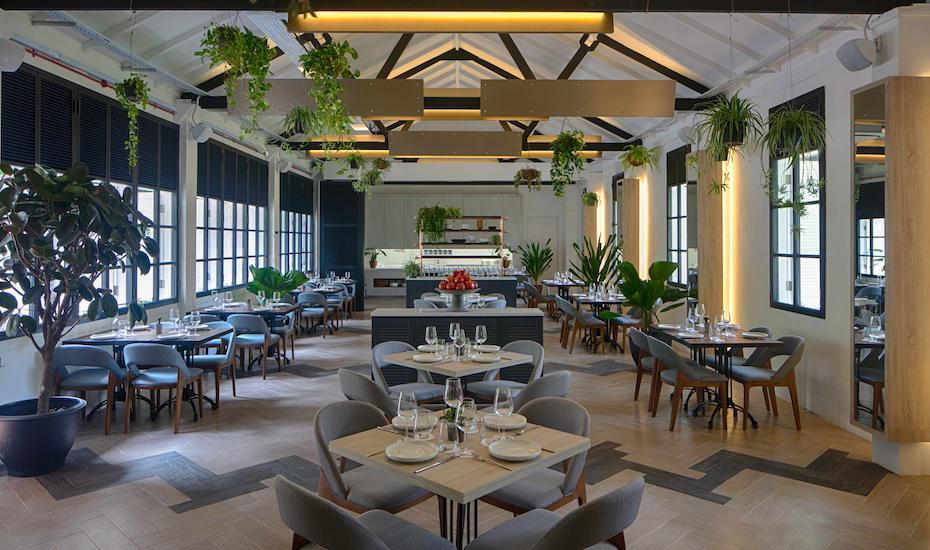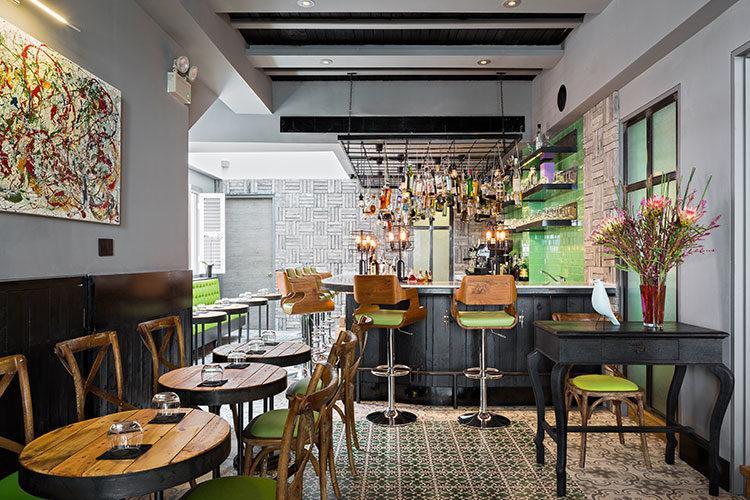The first image is the image on the left, the second image is the image on the right. Examine the images to the left and right. Is the description "Some tables have glass candle holders on them." accurate? Answer yes or no. Yes. The first image is the image on the left, the second image is the image on the right. Given the left and right images, does the statement "In one image, green things are suspended from the ceiling over a dining area that includes square tables for four." hold true? Answer yes or no. Yes. 